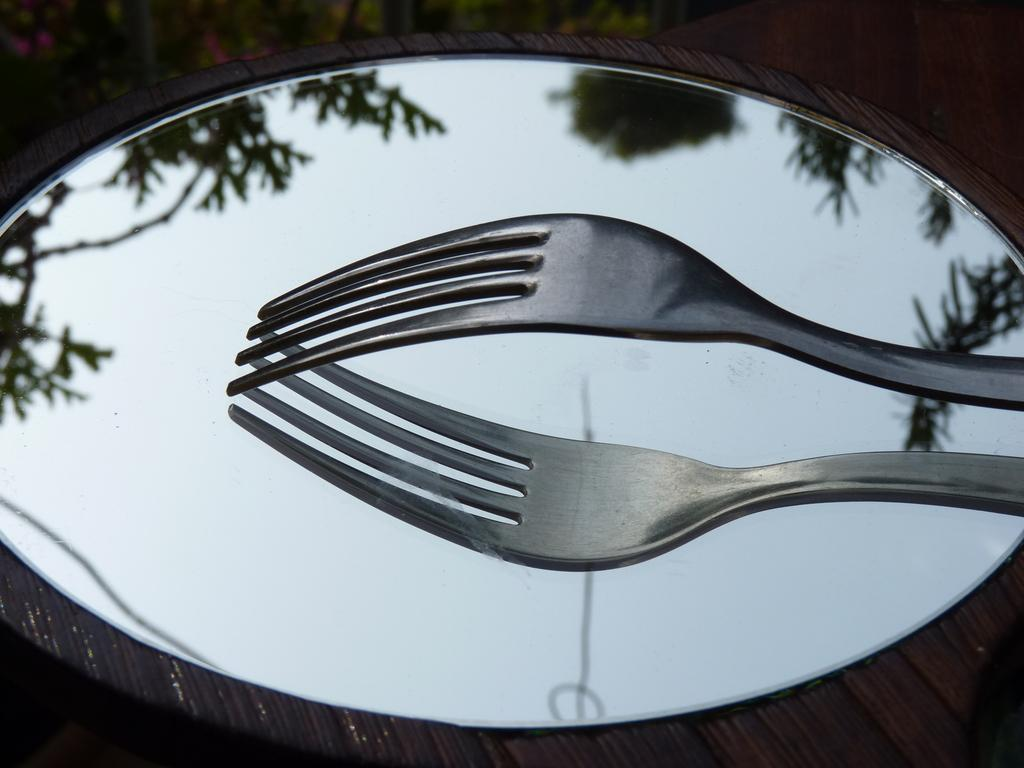What object is placed on the mirror in the image? There is a fork on the mirror in the image. What can be seen in the reflection of the mirror? The reflection of trees is visible in the mirror. What type of suit is hanging on the mirror in the image? There is no suit present in the image; it only features a fork on the mirror and the reflection of trees. 